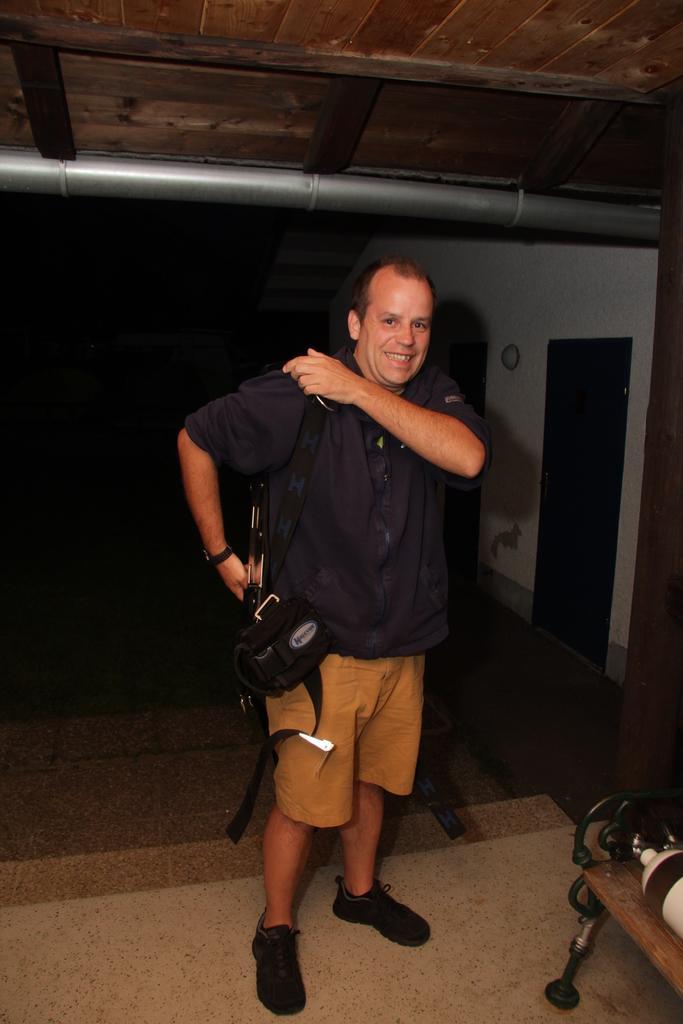Can you describe this image briefly? In this picture there is a man standing and smiling and carrying a bag. In the bottom right side of the image we can see objects on a bench. In the background of the image it is dark and we can see doors, wall and pipe. 